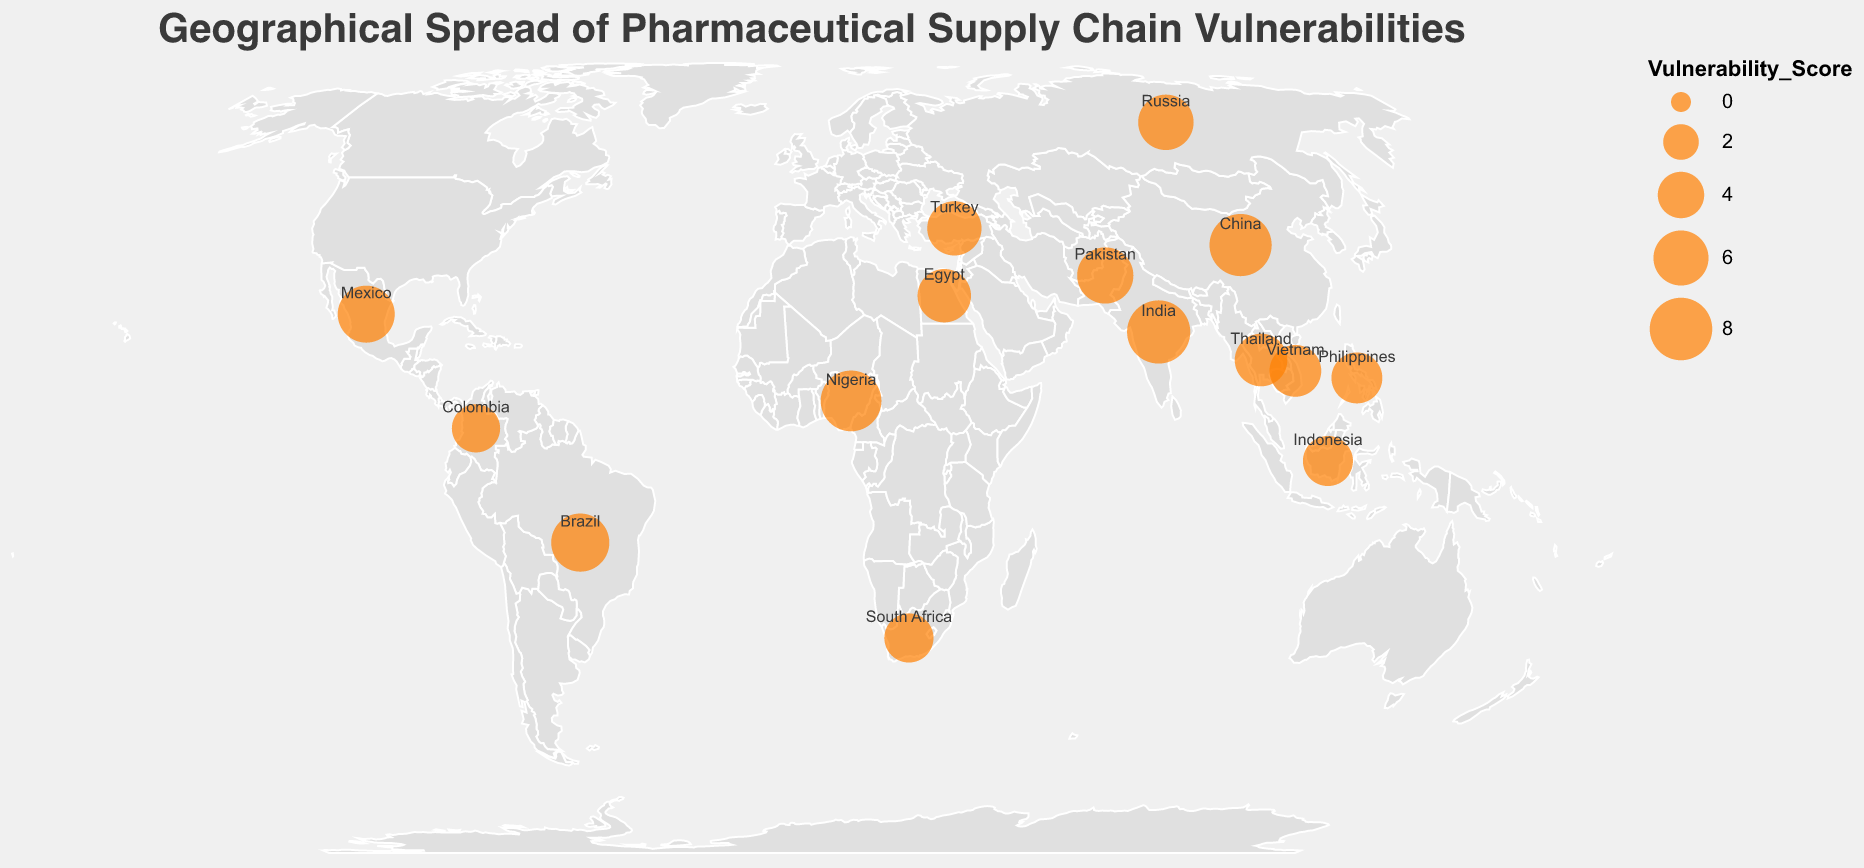How many countries are displayed on the map? There are 15 data points listed in the information provided. Each data point corresponds to a country that is shown on the map.
Answer: 15 Which country has the highest vulnerability score and what is the primary vulnerability identified for it? India has the highest vulnerability score of 8.2, and the primary vulnerability identified for it is raw material sourcing.
Answer: India, raw material sourcing Which country appears to be most vulnerable in terms of counterfeiting operations? By inspecting the primary vulnerabilities listed for each country, Mexico is identified as having counterfeiting operations as its primary vulnerability.
Answer: Mexico What is the average vulnerability score of the countries displayed on the map? Sum all the vulnerability scores and divide by the number of countries (15). (8.2 + 7.9 + 7.5 + 6.8 + 6.5 + 6.3 + 6.1 + 5.8 + 5.6 + 5.4 + 5.2 + 5.0 + 4.8 + 4.6 + 4.4) / 15 = 6.025
Answer: 6.025 Which countries have a vulnerability score greater than 6.5? Inspect and list the countries with vulnerability scores larger than 6.5: India (8.2), China (7.9), Nigeria (7.5), Brazil (6.8).
Answer: India, China, Nigeria, Brazil What common vulnerability is shared by countries with vulnerability scores between 5.0 and 6.0? Inspect the primary vulnerabilities of countries with scores in the range 5.0 to 6.0: Turkey (packaging integrity), Egypt (cold chain management), Thailand (documentation authenticity), Vietnam (quality testing facilities), Philippines (recall effectiveness). No single vulnerability is repeated in these countries.
Answer: None Compare the vulnerability of China and Russia in terms of their primary vulnerabilities and scores. China’s primary vulnerability is manufacturing quality control with a score of 7.9, while Russia’s primary vulnerability is regulatory oversight gaps with a score of 6.1.
Answer: China has a higher score and manufacturing quality control, Russia has a lower score and regulatory oversight gaps Which country in South America has the lowest vulnerability score, and what is the score? The countries in South America listed are Brazil and Colombia. Colombia has the lower score of 4.4.
Answer: Colombia, 4.4 What is the median vulnerability score of all the countries listed? List all vulnerability scores in ascending order and find the middle value: 4.4, 4.6, 4.8, 5.0, 5.2, 5.4, 5.6, 5.8, 6.1, 6.3, 6.5, 6.8, 7.5, 7.9, 8.2. The middle value (8th value) in this ordered list is 5.8.
Answer: 5.8 